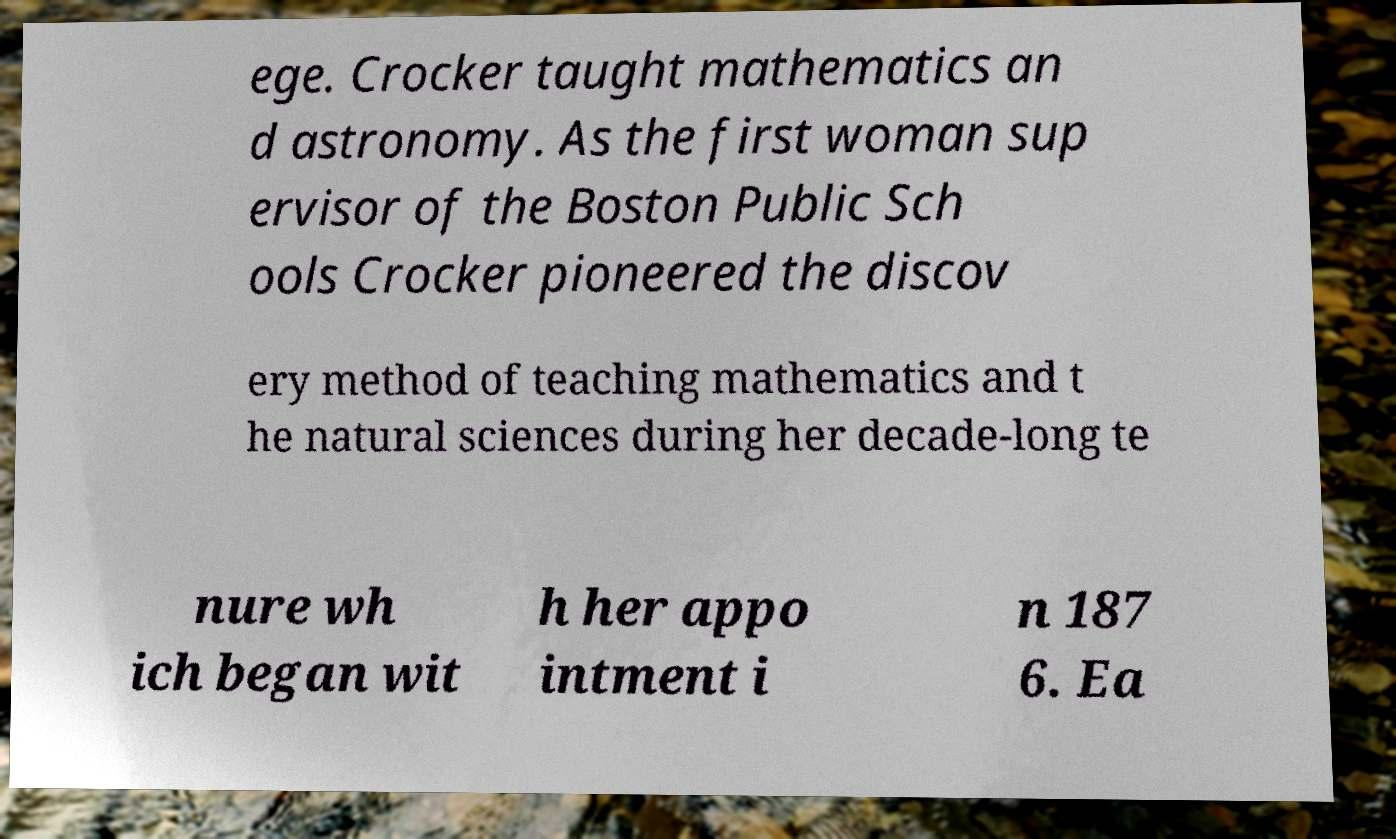There's text embedded in this image that I need extracted. Can you transcribe it verbatim? ege. Crocker taught mathematics an d astronomy. As the first woman sup ervisor of the Boston Public Sch ools Crocker pioneered the discov ery method of teaching mathematics and t he natural sciences during her decade-long te nure wh ich began wit h her appo intment i n 187 6. Ea 